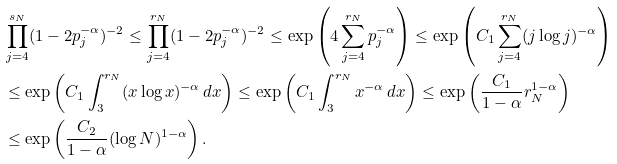Convert formula to latex. <formula><loc_0><loc_0><loc_500><loc_500>& \prod _ { j = 4 } ^ { s _ { N } } ( 1 - 2 p _ { j } ^ { - \alpha } ) ^ { - 2 } \leq \prod _ { j = 4 } ^ { r _ { N } } ( 1 - 2 p _ { j } ^ { - \alpha } ) ^ { - 2 } \leq \exp \left ( 4 \sum _ { j = 4 } ^ { r _ { N } } p _ { j } ^ { - \alpha } \right ) \leq \exp \left ( C _ { 1 } \sum _ { j = 4 } ^ { r _ { N } } ( j \log j ) ^ { - \alpha } \right ) \\ & \leq \exp \left ( C _ { 1 } \int _ { 3 } ^ { r _ { N } } ( x \log x ) ^ { - \alpha } \, d x \right ) \leq \exp \left ( C _ { 1 } \int _ { 3 } ^ { r _ { N } } x ^ { - \alpha } \, d x \right ) \leq \exp \left ( \frac { C _ { 1 } } { 1 - \alpha } r _ { N } ^ { 1 - \alpha } \right ) \\ & \leq \exp \left ( \frac { C _ { 2 } } { 1 - \alpha } ( \log N ) ^ { 1 - \alpha } \right ) .</formula> 